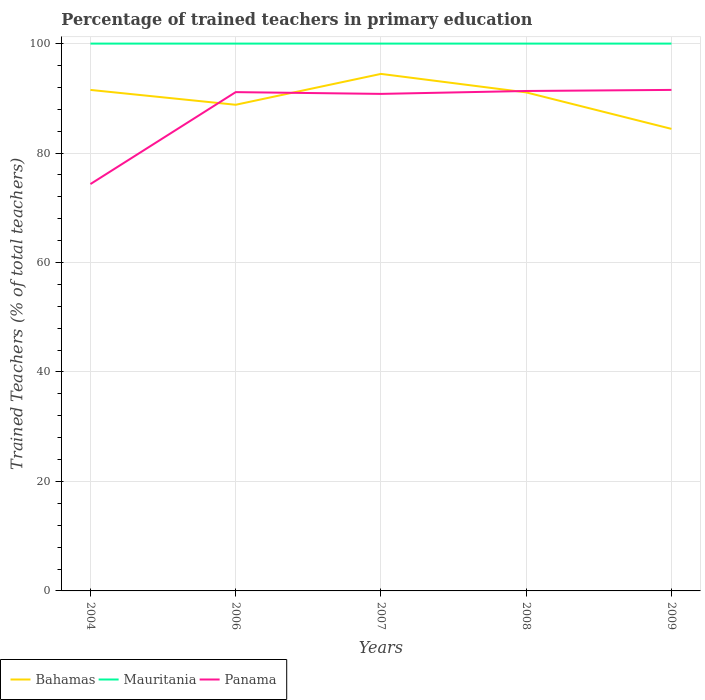Is the number of lines equal to the number of legend labels?
Your answer should be very brief. Yes. Across all years, what is the maximum percentage of trained teachers in Mauritania?
Ensure brevity in your answer.  100. What is the total percentage of trained teachers in Mauritania in the graph?
Make the answer very short. 0. What is the difference between the highest and the second highest percentage of trained teachers in Mauritania?
Your response must be concise. 0. How many years are there in the graph?
Offer a terse response. 5. Are the values on the major ticks of Y-axis written in scientific E-notation?
Give a very brief answer. No. Does the graph contain any zero values?
Your answer should be compact. No. How many legend labels are there?
Offer a very short reply. 3. How are the legend labels stacked?
Your response must be concise. Horizontal. What is the title of the graph?
Offer a very short reply. Percentage of trained teachers in primary education. Does "New Zealand" appear as one of the legend labels in the graph?
Keep it short and to the point. No. What is the label or title of the Y-axis?
Your answer should be very brief. Trained Teachers (% of total teachers). What is the Trained Teachers (% of total teachers) of Bahamas in 2004?
Ensure brevity in your answer.  91.53. What is the Trained Teachers (% of total teachers) in Mauritania in 2004?
Provide a short and direct response. 100. What is the Trained Teachers (% of total teachers) in Panama in 2004?
Offer a very short reply. 74.34. What is the Trained Teachers (% of total teachers) of Bahamas in 2006?
Offer a terse response. 88.82. What is the Trained Teachers (% of total teachers) of Panama in 2006?
Your response must be concise. 91.13. What is the Trained Teachers (% of total teachers) of Bahamas in 2007?
Your answer should be compact. 94.46. What is the Trained Teachers (% of total teachers) in Mauritania in 2007?
Offer a very short reply. 100. What is the Trained Teachers (% of total teachers) in Panama in 2007?
Give a very brief answer. 90.81. What is the Trained Teachers (% of total teachers) in Bahamas in 2008?
Offer a terse response. 91.08. What is the Trained Teachers (% of total teachers) of Panama in 2008?
Offer a very short reply. 91.34. What is the Trained Teachers (% of total teachers) in Bahamas in 2009?
Ensure brevity in your answer.  84.42. What is the Trained Teachers (% of total teachers) of Mauritania in 2009?
Your answer should be very brief. 100. What is the Trained Teachers (% of total teachers) in Panama in 2009?
Give a very brief answer. 91.54. Across all years, what is the maximum Trained Teachers (% of total teachers) of Bahamas?
Your answer should be very brief. 94.46. Across all years, what is the maximum Trained Teachers (% of total teachers) of Panama?
Ensure brevity in your answer.  91.54. Across all years, what is the minimum Trained Teachers (% of total teachers) of Bahamas?
Give a very brief answer. 84.42. Across all years, what is the minimum Trained Teachers (% of total teachers) in Mauritania?
Your answer should be compact. 100. Across all years, what is the minimum Trained Teachers (% of total teachers) of Panama?
Your answer should be compact. 74.34. What is the total Trained Teachers (% of total teachers) of Bahamas in the graph?
Provide a short and direct response. 450.32. What is the total Trained Teachers (% of total teachers) in Mauritania in the graph?
Offer a terse response. 500. What is the total Trained Teachers (% of total teachers) in Panama in the graph?
Provide a succinct answer. 439.16. What is the difference between the Trained Teachers (% of total teachers) of Bahamas in 2004 and that in 2006?
Provide a succinct answer. 2.71. What is the difference between the Trained Teachers (% of total teachers) of Panama in 2004 and that in 2006?
Ensure brevity in your answer.  -16.8. What is the difference between the Trained Teachers (% of total teachers) of Bahamas in 2004 and that in 2007?
Offer a very short reply. -2.93. What is the difference between the Trained Teachers (% of total teachers) of Panama in 2004 and that in 2007?
Make the answer very short. -16.47. What is the difference between the Trained Teachers (% of total teachers) in Bahamas in 2004 and that in 2008?
Your answer should be very brief. 0.45. What is the difference between the Trained Teachers (% of total teachers) in Mauritania in 2004 and that in 2008?
Provide a succinct answer. 0. What is the difference between the Trained Teachers (% of total teachers) in Panama in 2004 and that in 2008?
Offer a terse response. -17. What is the difference between the Trained Teachers (% of total teachers) in Bahamas in 2004 and that in 2009?
Offer a very short reply. 7.11. What is the difference between the Trained Teachers (% of total teachers) of Panama in 2004 and that in 2009?
Give a very brief answer. -17.2. What is the difference between the Trained Teachers (% of total teachers) of Bahamas in 2006 and that in 2007?
Provide a succinct answer. -5.64. What is the difference between the Trained Teachers (% of total teachers) in Mauritania in 2006 and that in 2007?
Offer a terse response. 0. What is the difference between the Trained Teachers (% of total teachers) in Panama in 2006 and that in 2007?
Offer a very short reply. 0.32. What is the difference between the Trained Teachers (% of total teachers) of Bahamas in 2006 and that in 2008?
Provide a short and direct response. -2.26. What is the difference between the Trained Teachers (% of total teachers) of Panama in 2006 and that in 2008?
Your response must be concise. -0.21. What is the difference between the Trained Teachers (% of total teachers) in Bahamas in 2006 and that in 2009?
Provide a short and direct response. 4.4. What is the difference between the Trained Teachers (% of total teachers) of Mauritania in 2006 and that in 2009?
Ensure brevity in your answer.  0. What is the difference between the Trained Teachers (% of total teachers) of Panama in 2006 and that in 2009?
Offer a very short reply. -0.41. What is the difference between the Trained Teachers (% of total teachers) of Bahamas in 2007 and that in 2008?
Offer a terse response. 3.38. What is the difference between the Trained Teachers (% of total teachers) in Mauritania in 2007 and that in 2008?
Offer a very short reply. 0. What is the difference between the Trained Teachers (% of total teachers) of Panama in 2007 and that in 2008?
Your response must be concise. -0.53. What is the difference between the Trained Teachers (% of total teachers) of Bahamas in 2007 and that in 2009?
Keep it short and to the point. 10.04. What is the difference between the Trained Teachers (% of total teachers) of Panama in 2007 and that in 2009?
Provide a succinct answer. -0.73. What is the difference between the Trained Teachers (% of total teachers) of Bahamas in 2008 and that in 2009?
Provide a succinct answer. 6.66. What is the difference between the Trained Teachers (% of total teachers) of Mauritania in 2008 and that in 2009?
Make the answer very short. 0. What is the difference between the Trained Teachers (% of total teachers) in Panama in 2008 and that in 2009?
Provide a succinct answer. -0.2. What is the difference between the Trained Teachers (% of total teachers) in Bahamas in 2004 and the Trained Teachers (% of total teachers) in Mauritania in 2006?
Provide a succinct answer. -8.47. What is the difference between the Trained Teachers (% of total teachers) of Bahamas in 2004 and the Trained Teachers (% of total teachers) of Panama in 2006?
Provide a short and direct response. 0.4. What is the difference between the Trained Teachers (% of total teachers) of Mauritania in 2004 and the Trained Teachers (% of total teachers) of Panama in 2006?
Your response must be concise. 8.87. What is the difference between the Trained Teachers (% of total teachers) in Bahamas in 2004 and the Trained Teachers (% of total teachers) in Mauritania in 2007?
Make the answer very short. -8.47. What is the difference between the Trained Teachers (% of total teachers) in Bahamas in 2004 and the Trained Teachers (% of total teachers) in Panama in 2007?
Provide a succinct answer. 0.72. What is the difference between the Trained Teachers (% of total teachers) of Mauritania in 2004 and the Trained Teachers (% of total teachers) of Panama in 2007?
Ensure brevity in your answer.  9.19. What is the difference between the Trained Teachers (% of total teachers) in Bahamas in 2004 and the Trained Teachers (% of total teachers) in Mauritania in 2008?
Give a very brief answer. -8.47. What is the difference between the Trained Teachers (% of total teachers) of Bahamas in 2004 and the Trained Teachers (% of total teachers) of Panama in 2008?
Give a very brief answer. 0.19. What is the difference between the Trained Teachers (% of total teachers) in Mauritania in 2004 and the Trained Teachers (% of total teachers) in Panama in 2008?
Offer a very short reply. 8.66. What is the difference between the Trained Teachers (% of total teachers) in Bahamas in 2004 and the Trained Teachers (% of total teachers) in Mauritania in 2009?
Offer a terse response. -8.47. What is the difference between the Trained Teachers (% of total teachers) of Bahamas in 2004 and the Trained Teachers (% of total teachers) of Panama in 2009?
Your answer should be compact. -0. What is the difference between the Trained Teachers (% of total teachers) of Mauritania in 2004 and the Trained Teachers (% of total teachers) of Panama in 2009?
Ensure brevity in your answer.  8.46. What is the difference between the Trained Teachers (% of total teachers) of Bahamas in 2006 and the Trained Teachers (% of total teachers) of Mauritania in 2007?
Offer a terse response. -11.18. What is the difference between the Trained Teachers (% of total teachers) of Bahamas in 2006 and the Trained Teachers (% of total teachers) of Panama in 2007?
Your answer should be very brief. -1.99. What is the difference between the Trained Teachers (% of total teachers) of Mauritania in 2006 and the Trained Teachers (% of total teachers) of Panama in 2007?
Offer a very short reply. 9.19. What is the difference between the Trained Teachers (% of total teachers) in Bahamas in 2006 and the Trained Teachers (% of total teachers) in Mauritania in 2008?
Offer a very short reply. -11.18. What is the difference between the Trained Teachers (% of total teachers) in Bahamas in 2006 and the Trained Teachers (% of total teachers) in Panama in 2008?
Give a very brief answer. -2.52. What is the difference between the Trained Teachers (% of total teachers) of Mauritania in 2006 and the Trained Teachers (% of total teachers) of Panama in 2008?
Provide a short and direct response. 8.66. What is the difference between the Trained Teachers (% of total teachers) of Bahamas in 2006 and the Trained Teachers (% of total teachers) of Mauritania in 2009?
Your response must be concise. -11.18. What is the difference between the Trained Teachers (% of total teachers) of Bahamas in 2006 and the Trained Teachers (% of total teachers) of Panama in 2009?
Your answer should be compact. -2.72. What is the difference between the Trained Teachers (% of total teachers) of Mauritania in 2006 and the Trained Teachers (% of total teachers) of Panama in 2009?
Your answer should be compact. 8.46. What is the difference between the Trained Teachers (% of total teachers) in Bahamas in 2007 and the Trained Teachers (% of total teachers) in Mauritania in 2008?
Your answer should be compact. -5.54. What is the difference between the Trained Teachers (% of total teachers) in Bahamas in 2007 and the Trained Teachers (% of total teachers) in Panama in 2008?
Provide a succinct answer. 3.12. What is the difference between the Trained Teachers (% of total teachers) of Mauritania in 2007 and the Trained Teachers (% of total teachers) of Panama in 2008?
Make the answer very short. 8.66. What is the difference between the Trained Teachers (% of total teachers) in Bahamas in 2007 and the Trained Teachers (% of total teachers) in Mauritania in 2009?
Your response must be concise. -5.54. What is the difference between the Trained Teachers (% of total teachers) of Bahamas in 2007 and the Trained Teachers (% of total teachers) of Panama in 2009?
Give a very brief answer. 2.92. What is the difference between the Trained Teachers (% of total teachers) in Mauritania in 2007 and the Trained Teachers (% of total teachers) in Panama in 2009?
Give a very brief answer. 8.46. What is the difference between the Trained Teachers (% of total teachers) in Bahamas in 2008 and the Trained Teachers (% of total teachers) in Mauritania in 2009?
Your answer should be compact. -8.92. What is the difference between the Trained Teachers (% of total teachers) in Bahamas in 2008 and the Trained Teachers (% of total teachers) in Panama in 2009?
Keep it short and to the point. -0.45. What is the difference between the Trained Teachers (% of total teachers) of Mauritania in 2008 and the Trained Teachers (% of total teachers) of Panama in 2009?
Offer a very short reply. 8.46. What is the average Trained Teachers (% of total teachers) of Bahamas per year?
Offer a terse response. 90.06. What is the average Trained Teachers (% of total teachers) in Mauritania per year?
Provide a short and direct response. 100. What is the average Trained Teachers (% of total teachers) in Panama per year?
Make the answer very short. 87.83. In the year 2004, what is the difference between the Trained Teachers (% of total teachers) of Bahamas and Trained Teachers (% of total teachers) of Mauritania?
Ensure brevity in your answer.  -8.47. In the year 2004, what is the difference between the Trained Teachers (% of total teachers) in Bahamas and Trained Teachers (% of total teachers) in Panama?
Your response must be concise. 17.2. In the year 2004, what is the difference between the Trained Teachers (% of total teachers) in Mauritania and Trained Teachers (% of total teachers) in Panama?
Your response must be concise. 25.66. In the year 2006, what is the difference between the Trained Teachers (% of total teachers) in Bahamas and Trained Teachers (% of total teachers) in Mauritania?
Your answer should be very brief. -11.18. In the year 2006, what is the difference between the Trained Teachers (% of total teachers) of Bahamas and Trained Teachers (% of total teachers) of Panama?
Ensure brevity in your answer.  -2.31. In the year 2006, what is the difference between the Trained Teachers (% of total teachers) in Mauritania and Trained Teachers (% of total teachers) in Panama?
Offer a very short reply. 8.87. In the year 2007, what is the difference between the Trained Teachers (% of total teachers) of Bahamas and Trained Teachers (% of total teachers) of Mauritania?
Offer a terse response. -5.54. In the year 2007, what is the difference between the Trained Teachers (% of total teachers) of Bahamas and Trained Teachers (% of total teachers) of Panama?
Give a very brief answer. 3.65. In the year 2007, what is the difference between the Trained Teachers (% of total teachers) of Mauritania and Trained Teachers (% of total teachers) of Panama?
Your answer should be very brief. 9.19. In the year 2008, what is the difference between the Trained Teachers (% of total teachers) of Bahamas and Trained Teachers (% of total teachers) of Mauritania?
Offer a very short reply. -8.92. In the year 2008, what is the difference between the Trained Teachers (% of total teachers) of Bahamas and Trained Teachers (% of total teachers) of Panama?
Offer a very short reply. -0.26. In the year 2008, what is the difference between the Trained Teachers (% of total teachers) in Mauritania and Trained Teachers (% of total teachers) in Panama?
Provide a short and direct response. 8.66. In the year 2009, what is the difference between the Trained Teachers (% of total teachers) in Bahamas and Trained Teachers (% of total teachers) in Mauritania?
Provide a short and direct response. -15.58. In the year 2009, what is the difference between the Trained Teachers (% of total teachers) of Bahamas and Trained Teachers (% of total teachers) of Panama?
Your answer should be compact. -7.12. In the year 2009, what is the difference between the Trained Teachers (% of total teachers) of Mauritania and Trained Teachers (% of total teachers) of Panama?
Offer a very short reply. 8.46. What is the ratio of the Trained Teachers (% of total teachers) in Bahamas in 2004 to that in 2006?
Provide a succinct answer. 1.03. What is the ratio of the Trained Teachers (% of total teachers) in Panama in 2004 to that in 2006?
Your answer should be very brief. 0.82. What is the ratio of the Trained Teachers (% of total teachers) of Bahamas in 2004 to that in 2007?
Your answer should be very brief. 0.97. What is the ratio of the Trained Teachers (% of total teachers) of Mauritania in 2004 to that in 2007?
Make the answer very short. 1. What is the ratio of the Trained Teachers (% of total teachers) of Panama in 2004 to that in 2007?
Provide a succinct answer. 0.82. What is the ratio of the Trained Teachers (% of total teachers) of Bahamas in 2004 to that in 2008?
Offer a very short reply. 1. What is the ratio of the Trained Teachers (% of total teachers) of Mauritania in 2004 to that in 2008?
Your answer should be compact. 1. What is the ratio of the Trained Teachers (% of total teachers) in Panama in 2004 to that in 2008?
Ensure brevity in your answer.  0.81. What is the ratio of the Trained Teachers (% of total teachers) in Bahamas in 2004 to that in 2009?
Your answer should be very brief. 1.08. What is the ratio of the Trained Teachers (% of total teachers) in Mauritania in 2004 to that in 2009?
Keep it short and to the point. 1. What is the ratio of the Trained Teachers (% of total teachers) of Panama in 2004 to that in 2009?
Keep it short and to the point. 0.81. What is the ratio of the Trained Teachers (% of total teachers) of Bahamas in 2006 to that in 2007?
Make the answer very short. 0.94. What is the ratio of the Trained Teachers (% of total teachers) in Panama in 2006 to that in 2007?
Your response must be concise. 1. What is the ratio of the Trained Teachers (% of total teachers) of Bahamas in 2006 to that in 2008?
Keep it short and to the point. 0.98. What is the ratio of the Trained Teachers (% of total teachers) in Mauritania in 2006 to that in 2008?
Ensure brevity in your answer.  1. What is the ratio of the Trained Teachers (% of total teachers) in Panama in 2006 to that in 2008?
Ensure brevity in your answer.  1. What is the ratio of the Trained Teachers (% of total teachers) of Bahamas in 2006 to that in 2009?
Give a very brief answer. 1.05. What is the ratio of the Trained Teachers (% of total teachers) of Mauritania in 2006 to that in 2009?
Your answer should be very brief. 1. What is the ratio of the Trained Teachers (% of total teachers) of Panama in 2006 to that in 2009?
Provide a short and direct response. 1. What is the ratio of the Trained Teachers (% of total teachers) of Bahamas in 2007 to that in 2008?
Offer a very short reply. 1.04. What is the ratio of the Trained Teachers (% of total teachers) of Bahamas in 2007 to that in 2009?
Make the answer very short. 1.12. What is the ratio of the Trained Teachers (% of total teachers) in Bahamas in 2008 to that in 2009?
Your response must be concise. 1.08. What is the ratio of the Trained Teachers (% of total teachers) of Mauritania in 2008 to that in 2009?
Make the answer very short. 1. What is the ratio of the Trained Teachers (% of total teachers) of Panama in 2008 to that in 2009?
Keep it short and to the point. 1. What is the difference between the highest and the second highest Trained Teachers (% of total teachers) of Bahamas?
Your answer should be compact. 2.93. What is the difference between the highest and the second highest Trained Teachers (% of total teachers) of Panama?
Your answer should be very brief. 0.2. What is the difference between the highest and the lowest Trained Teachers (% of total teachers) of Bahamas?
Give a very brief answer. 10.04. What is the difference between the highest and the lowest Trained Teachers (% of total teachers) of Mauritania?
Your answer should be compact. 0. What is the difference between the highest and the lowest Trained Teachers (% of total teachers) of Panama?
Make the answer very short. 17.2. 